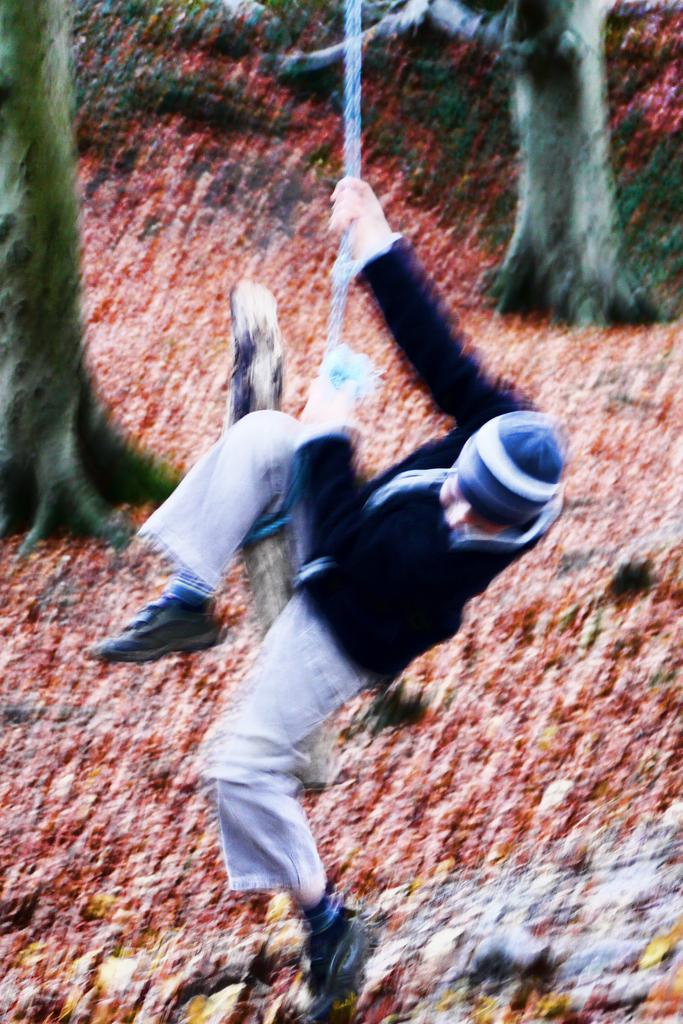Who is the main subject in the image? There is a boy in the image. What is the boy wearing? The boy is wearing a sweatshirt and a cap. What activity is the boy engaged in? The boy is swinging on a rope. How many trees are visible in the image? There are two trees visible in the image. What is the condition of the land in the image? The land is covered with dry leaves. What type of coast can be seen in the image? There is no coast visible in the image; it features a boy swinging on a rope in a land covered with dry leaves. What role does the army play in the image? There is no mention of an army or any military presence in the image. 